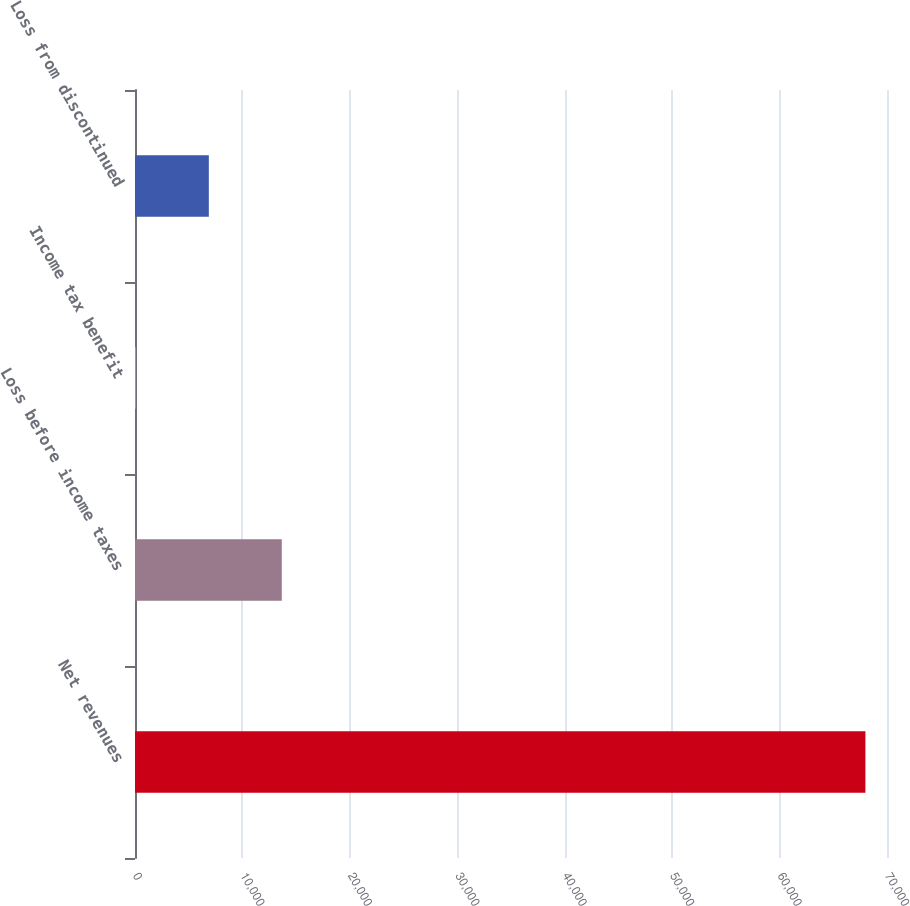<chart> <loc_0><loc_0><loc_500><loc_500><bar_chart><fcel>Net revenues<fcel>Loss before income taxes<fcel>Income tax benefit<fcel>Loss from discontinued<nl><fcel>67990<fcel>13663.6<fcel>82<fcel>6872.8<nl></chart> 